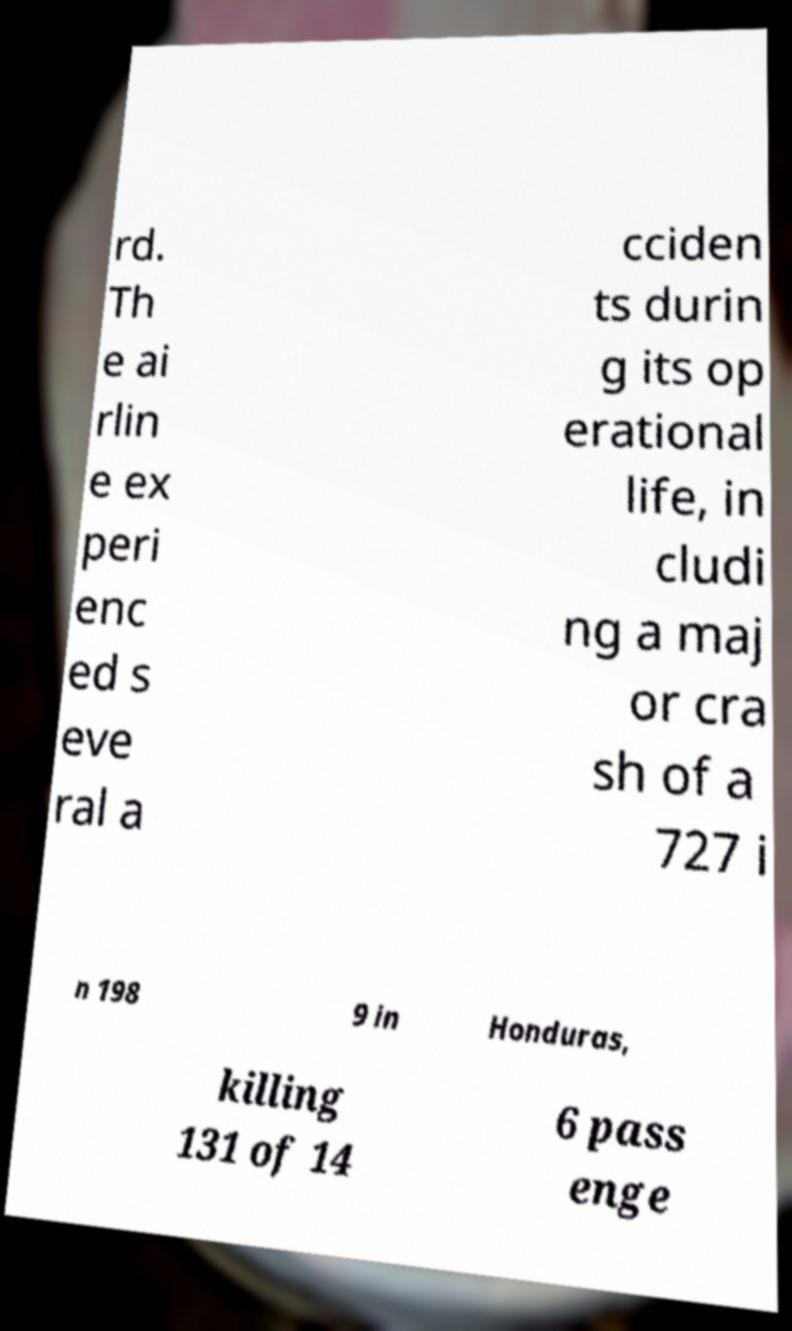There's text embedded in this image that I need extracted. Can you transcribe it verbatim? rd. Th e ai rlin e ex peri enc ed s eve ral a cciden ts durin g its op erational life, in cludi ng a maj or cra sh of a 727 i n 198 9 in Honduras, killing 131 of 14 6 pass enge 